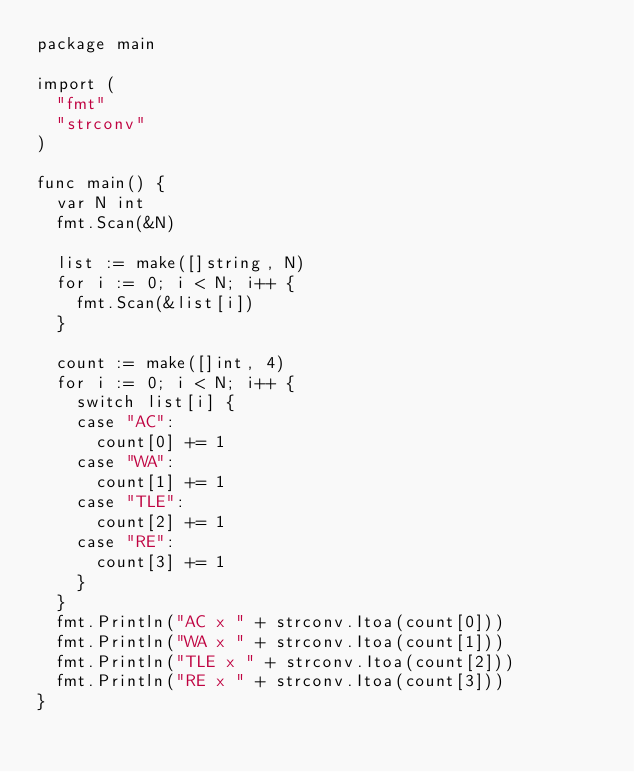Convert code to text. <code><loc_0><loc_0><loc_500><loc_500><_Go_>package main

import (
	"fmt"
	"strconv"
)

func main() {
	var N int
	fmt.Scan(&N)

	list := make([]string, N)
	for i := 0; i < N; i++ {
		fmt.Scan(&list[i])
	}

	count := make([]int, 4)
	for i := 0; i < N; i++ {
		switch list[i] {
		case "AC":
			count[0] += 1
		case "WA":
			count[1] += 1
		case "TLE":
			count[2] += 1
		case "RE":
			count[3] += 1
		}
	}
	fmt.Println("AC x " + strconv.Itoa(count[0]))
	fmt.Println("WA x " + strconv.Itoa(count[1]))
	fmt.Println("TLE x " + strconv.Itoa(count[2]))
	fmt.Println("RE x " + strconv.Itoa(count[3]))
}</code> 